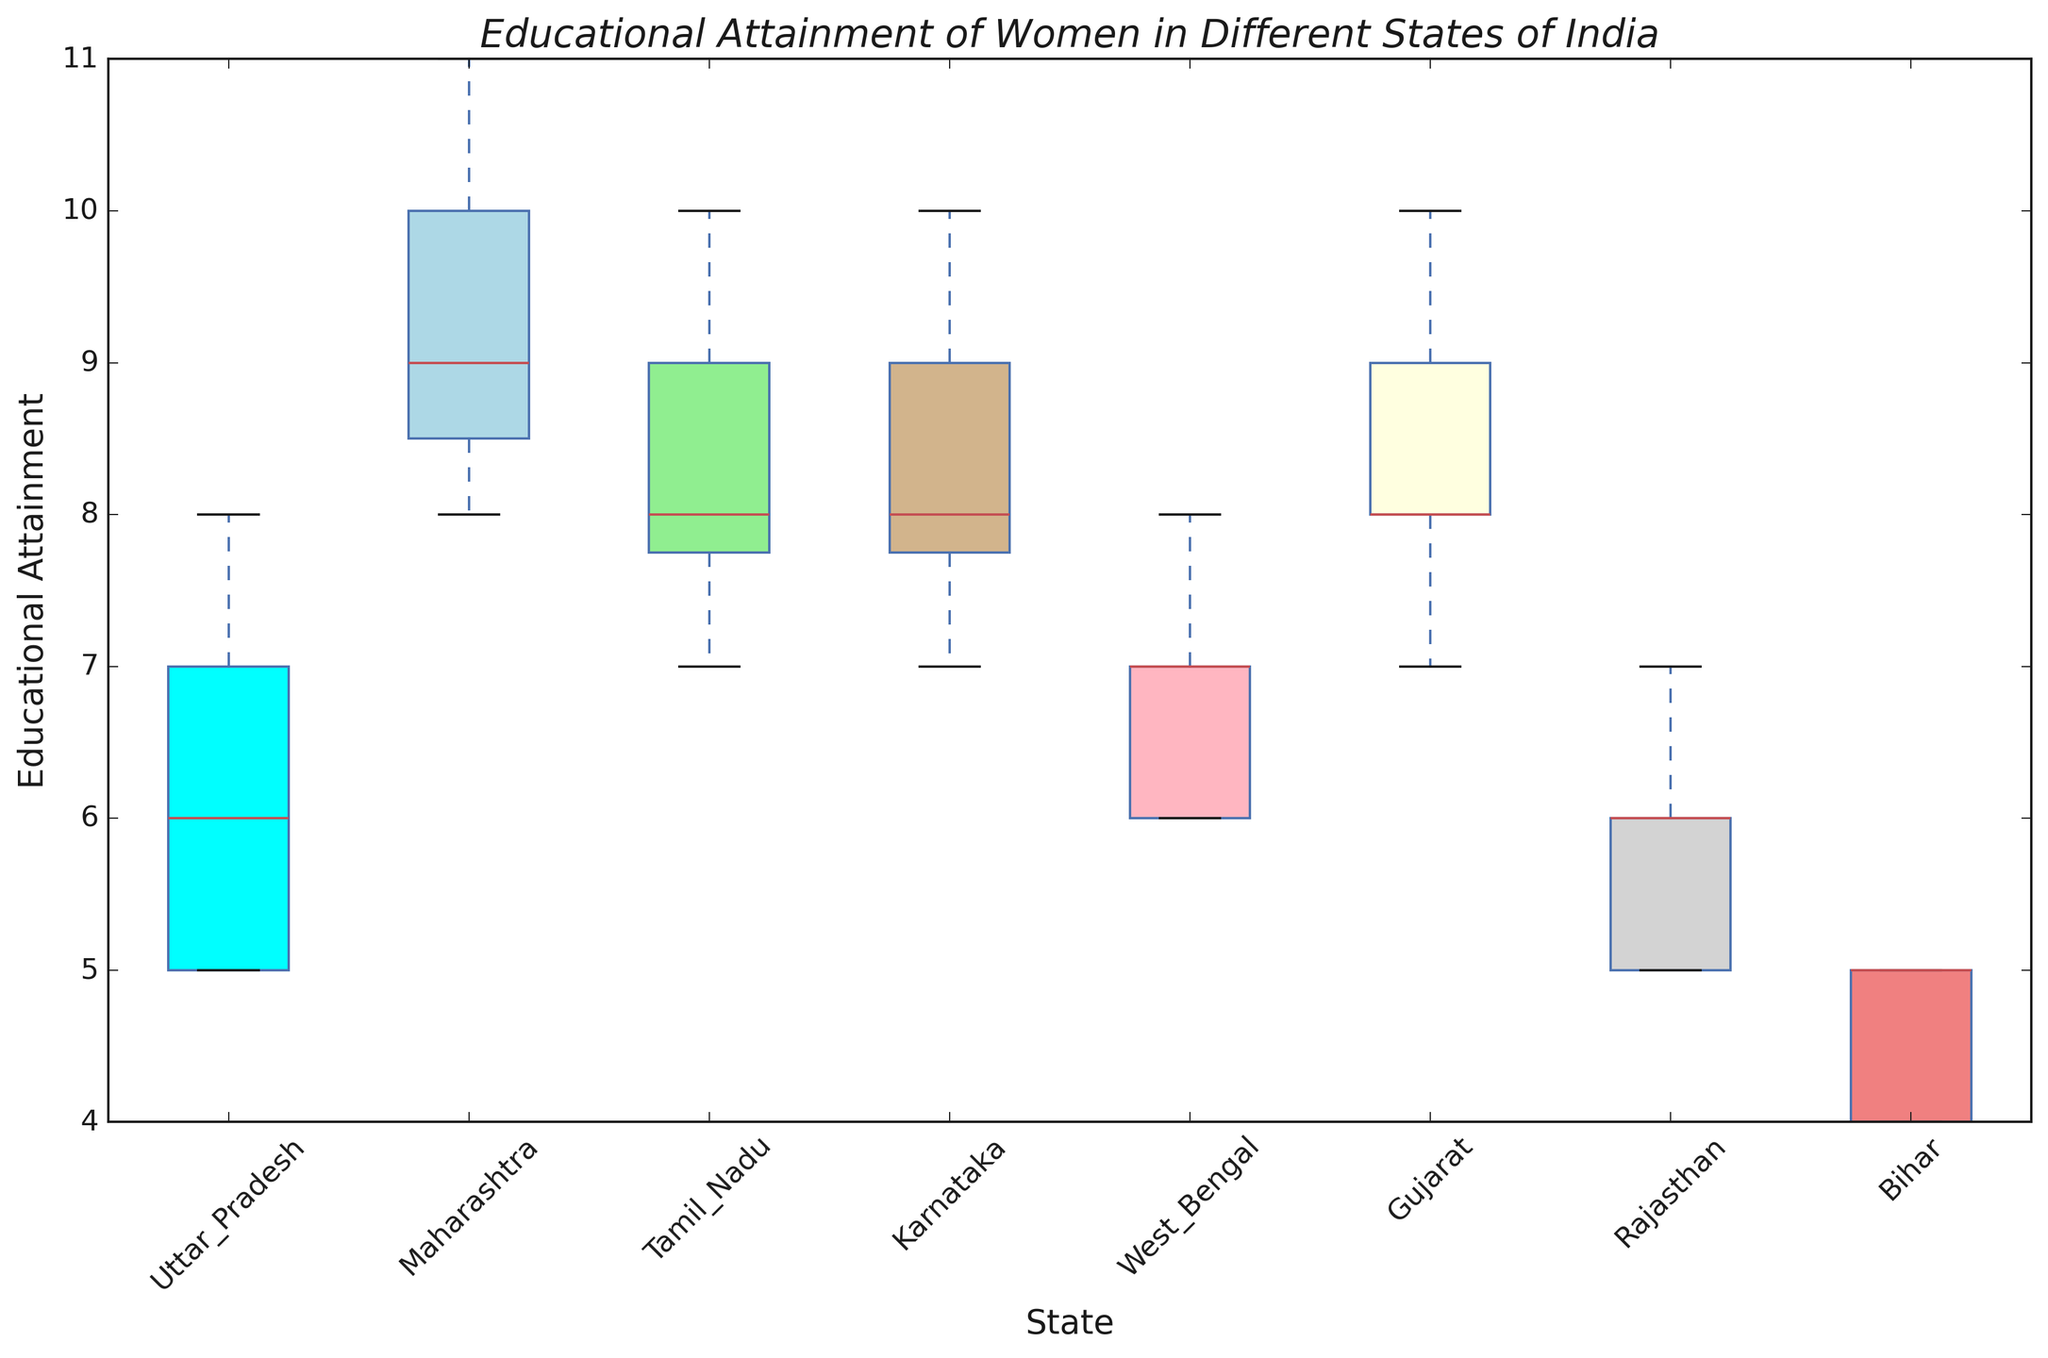What is the median educational attainment for women in Uttar Pradesh? To find the median, arrange the data for Uttar Pradesh (5, 5, 5, 6, 6, 7, 7, 8) in ascending order and identify the middle value. Since there are 8 data points, the median is the average of the 4th and 5th values (6 and 6).
Answer: 6 Which state has the highest median educational attainment? Compare the median values of all states: Maharashtra (9), Tamil Nadu (8), Karnataka (8), Gujarat (8), West Bengal (7), Uttar Pradesh (6), Rajasthan (6), and Bihar (5). Maharashtra has the highest median.
Answer: Maharashtra What is the interquartile range (IQR) for Tamil Nadu? To find the IQR, determine the first quartile (Q1) and third quartile (Q3) for Tamil Nadu's educational attainment data (7, 7, 8, 8, 8, 9, 9, 10). Q1 is the median of the first half (7.5), and Q3 is the median of the second half (9). IQR is Q3 - Q1 (9 - 7.5).
Answer: 1.5 Which state shows the smallest range of educational attainment values? The range is determined by the difference between the maximum and minimum educational attainment values for each state. Compare the ranges: Uttar Pradesh (8-5), Maharashtra (11-8), Tamil Nadu (10-7), Karnataka (10-7), Gujarat (10-7), West Bengal (8-6), Rajasthan (7-5), Bihar (5-4). Uttar Pradesh and Rajasthan have the smallest range of 3 years.
Answer: Rajasthan, Uttar Pradesh What is the overall distribution trend for educational attainment in Bihar? In the box plot for Bihar, the educational attainment values are quite low with a median at 5 and a very short box, indicating that most values are clustered around the lower end with little variability.
Answer: Low and clustered around 5 How does the educational attainment in West Bengal compare visually to Karnataka? West Bengal's box plot is lower on the y-axis, with lower median and data dispersed from 6 to 8. Karnataka's box plot shows higher median and similar range (7 to 10), indicating better educational features for women.
Answer: Karnataka is higher What is the average educational attainment of women in Maharashtra? Sum all educational attainment values in Maharashtra (8, 8, 10, 9, 11, 9, 10) to get 75, then divide by the number of data points (8).
Answer: 9.375, or approximately 9.4 Which states have outliers in their box plots? Identify any dots outside the whiskers in the box plots. None of the states display dots outside their whiskers, indicating no outliers.
Answer: None What is the maximum educational attainment value recorded in Gujarat? Look at the top whisker or edge of the box plot for Gujarat, which represents the maximum value. The highest value is 10.
Answer: 10 